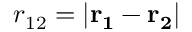Convert formula to latex. <formula><loc_0><loc_0><loc_500><loc_500>r _ { 1 2 } = | r _ { 1 } - r _ { 2 } |</formula> 